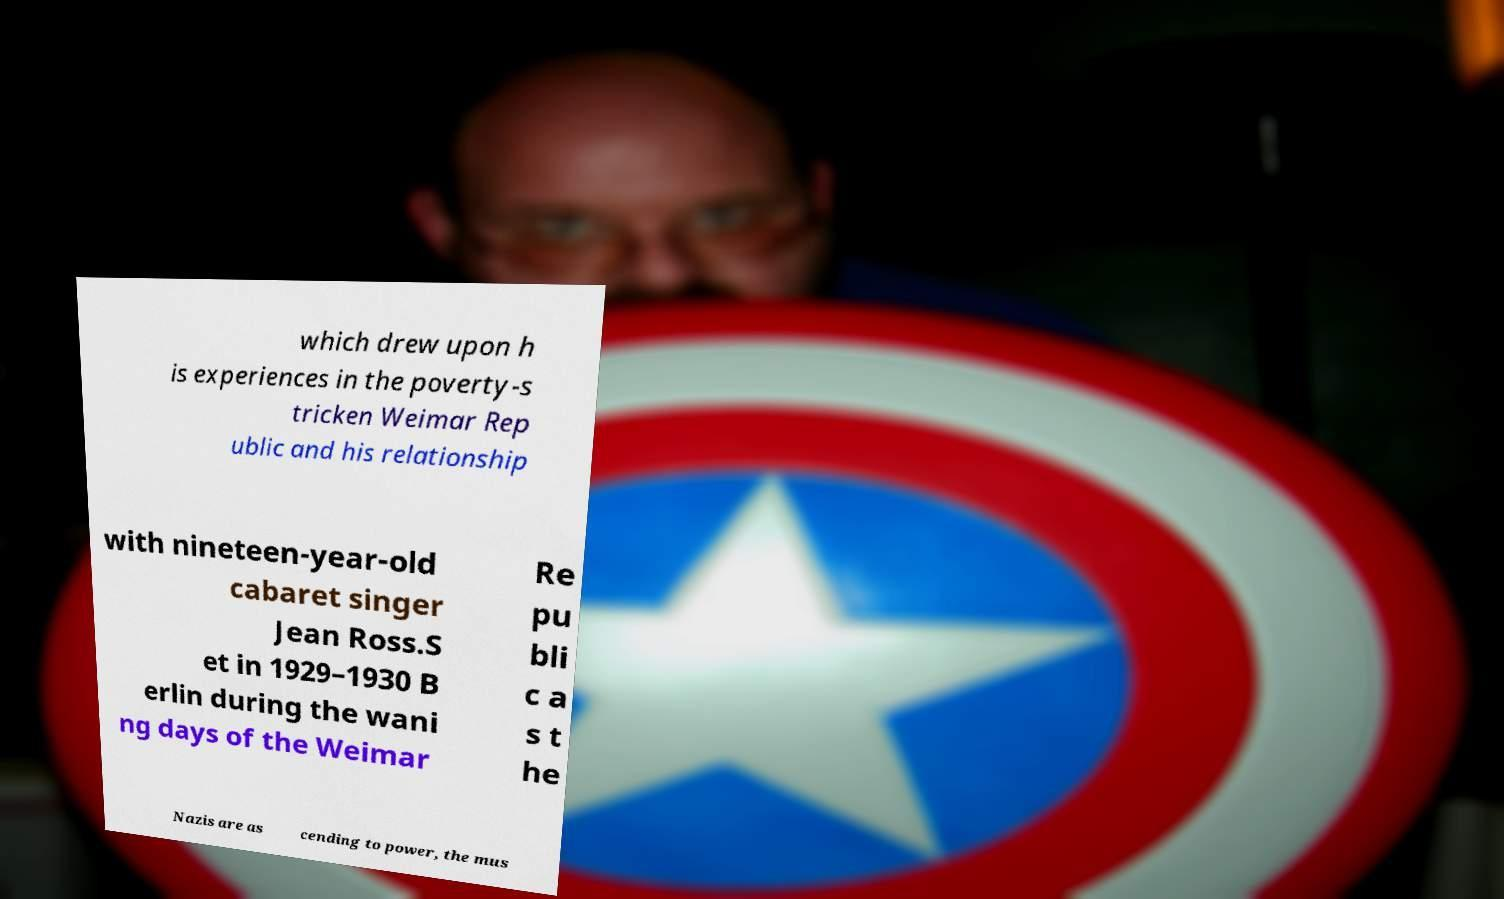I need the written content from this picture converted into text. Can you do that? which drew upon h is experiences in the poverty-s tricken Weimar Rep ublic and his relationship with nineteen-year-old cabaret singer Jean Ross.S et in 1929–1930 B erlin during the wani ng days of the Weimar Re pu bli c a s t he Nazis are as cending to power, the mus 